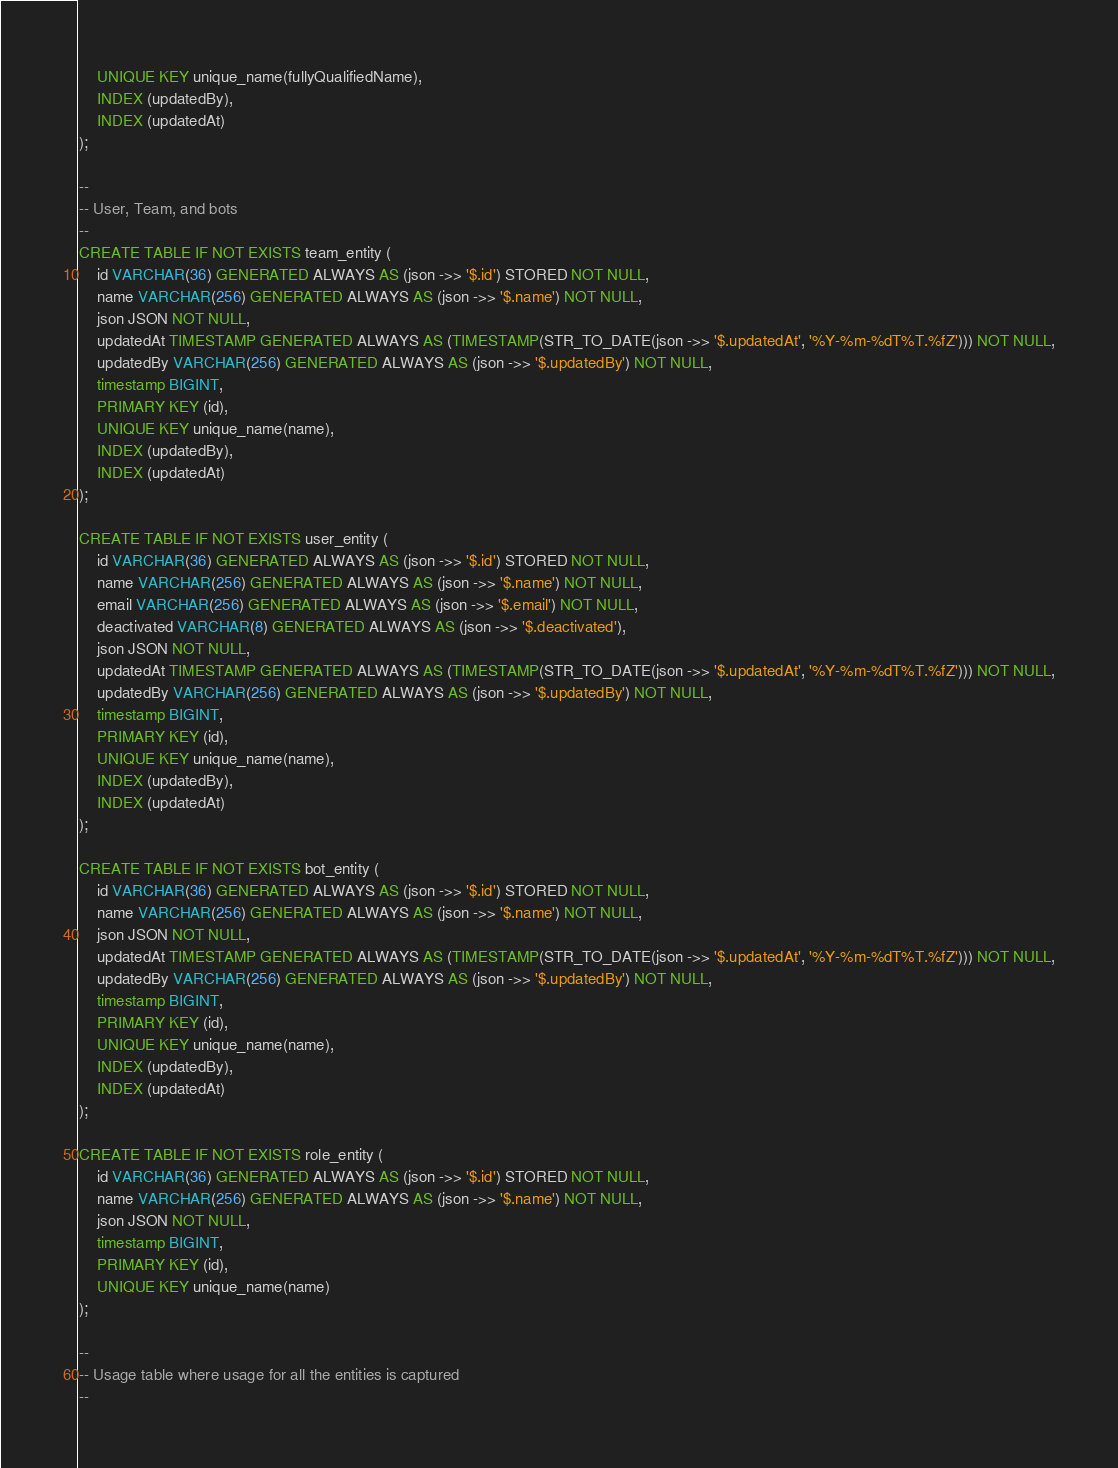<code> <loc_0><loc_0><loc_500><loc_500><_SQL_>    UNIQUE KEY unique_name(fullyQualifiedName),
    INDEX (updatedBy),
    INDEX (updatedAt)
);

--
-- User, Team, and bots
--
CREATE TABLE IF NOT EXISTS team_entity (
    id VARCHAR(36) GENERATED ALWAYS AS (json ->> '$.id') STORED NOT NULL,
    name VARCHAR(256) GENERATED ALWAYS AS (json ->> '$.name') NOT NULL,
    json JSON NOT NULL,
    updatedAt TIMESTAMP GENERATED ALWAYS AS (TIMESTAMP(STR_TO_DATE(json ->> '$.updatedAt', '%Y-%m-%dT%T.%fZ'))) NOT NULL,
    updatedBy VARCHAR(256) GENERATED ALWAYS AS (json ->> '$.updatedBy') NOT NULL,
    timestamp BIGINT,
    PRIMARY KEY (id),
    UNIQUE KEY unique_name(name),
    INDEX (updatedBy),
    INDEX (updatedAt)
);

CREATE TABLE IF NOT EXISTS user_entity (
    id VARCHAR(36) GENERATED ALWAYS AS (json ->> '$.id') STORED NOT NULL,
    name VARCHAR(256) GENERATED ALWAYS AS (json ->> '$.name') NOT NULL,
    email VARCHAR(256) GENERATED ALWAYS AS (json ->> '$.email') NOT NULL,
    deactivated VARCHAR(8) GENERATED ALWAYS AS (json ->> '$.deactivated'),
    json JSON NOT NULL,
    updatedAt TIMESTAMP GENERATED ALWAYS AS (TIMESTAMP(STR_TO_DATE(json ->> '$.updatedAt', '%Y-%m-%dT%T.%fZ'))) NOT NULL,
    updatedBy VARCHAR(256) GENERATED ALWAYS AS (json ->> '$.updatedBy') NOT NULL,
    timestamp BIGINT,
    PRIMARY KEY (id),
    UNIQUE KEY unique_name(name),
    INDEX (updatedBy),
    INDEX (updatedAt)
);

CREATE TABLE IF NOT EXISTS bot_entity (
    id VARCHAR(36) GENERATED ALWAYS AS (json ->> '$.id') STORED NOT NULL,
    name VARCHAR(256) GENERATED ALWAYS AS (json ->> '$.name') NOT NULL,
    json JSON NOT NULL,
    updatedAt TIMESTAMP GENERATED ALWAYS AS (TIMESTAMP(STR_TO_DATE(json ->> '$.updatedAt', '%Y-%m-%dT%T.%fZ'))) NOT NULL,
    updatedBy VARCHAR(256) GENERATED ALWAYS AS (json ->> '$.updatedBy') NOT NULL,
    timestamp BIGINT,
    PRIMARY KEY (id),
    UNIQUE KEY unique_name(name),
    INDEX (updatedBy),
    INDEX (updatedAt)
);

CREATE TABLE IF NOT EXISTS role_entity (
    id VARCHAR(36) GENERATED ALWAYS AS (json ->> '$.id') STORED NOT NULL,
    name VARCHAR(256) GENERATED ALWAYS AS (json ->> '$.name') NOT NULL,
    json JSON NOT NULL,
    timestamp BIGINT,
    PRIMARY KEY (id),
    UNIQUE KEY unique_name(name)
);

--
-- Usage table where usage for all the entities is captured
--</code> 